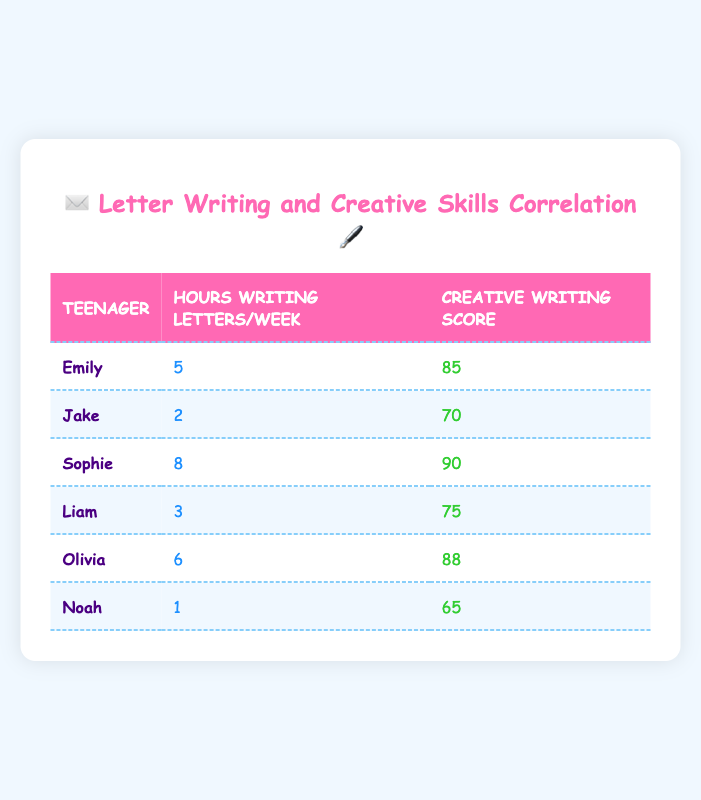What is the creative writing skills score of Sophie? Looking at the table, Sophie is listed as having a creative writing skills score of 90.
Answer: 90 How many hours does Noah spend writing letters per week? The table shows that Noah spends 1 hour writing letters per week.
Answer: 1 Which teenager writes letters for the most hours per week? By comparing the hours spent writing letters per week in the table, Sophie spends the most time at 8 hours.
Answer: Sophie What is the average creative writing skills score of all the teenagers? To find the average, we add up the scores: 85 + 70 + 90 + 75 + 88 + 65 = 473. There are 6 teenagers, so we divide by 6: 473 / 6 ≈ 78.83.
Answer: 78.83 Is there a teenager who writes for 4 hours a week? By checking the table, there is no mention of any teenager writing for exactly 4 hours a week; hence, the answer is no.
Answer: No What is the difference between the highest and lowest creative writing scores among the teenagers? The highest score is 90 (Sophie) and the lowest is 65 (Noah). The difference is 90 - 65 = 25.
Answer: 25 Which teenager has a creative writing skill score greater than their hours spent writing letters per week? By examining the table, Olivia has a score of 88 with 6 hours writing letters (88 > 6), and Emily has a score of 85 with 5 hours (85 > 5). Therefore, Olivia and Emily are both qualified.
Answer: Olivia and Emily If Liam increases his letter writing time by 1 hour, what would his total hours be? Liam currently spends 3 hours writing letters per week. Increasing this by 1 hour results in 3 + 1 = 4 hours.
Answer: 4 Who has the highest score per hour spent writing letters? To find this, we divide each score by the respective hours: Emily (85/5=17), Jake (70/2=35), Sophie (90/8=11.25), Liam (75/3=25), Olivia (88/6=14.67), Noah (65/1=65). Noah has the highest ratio at 65.
Answer: Noah 